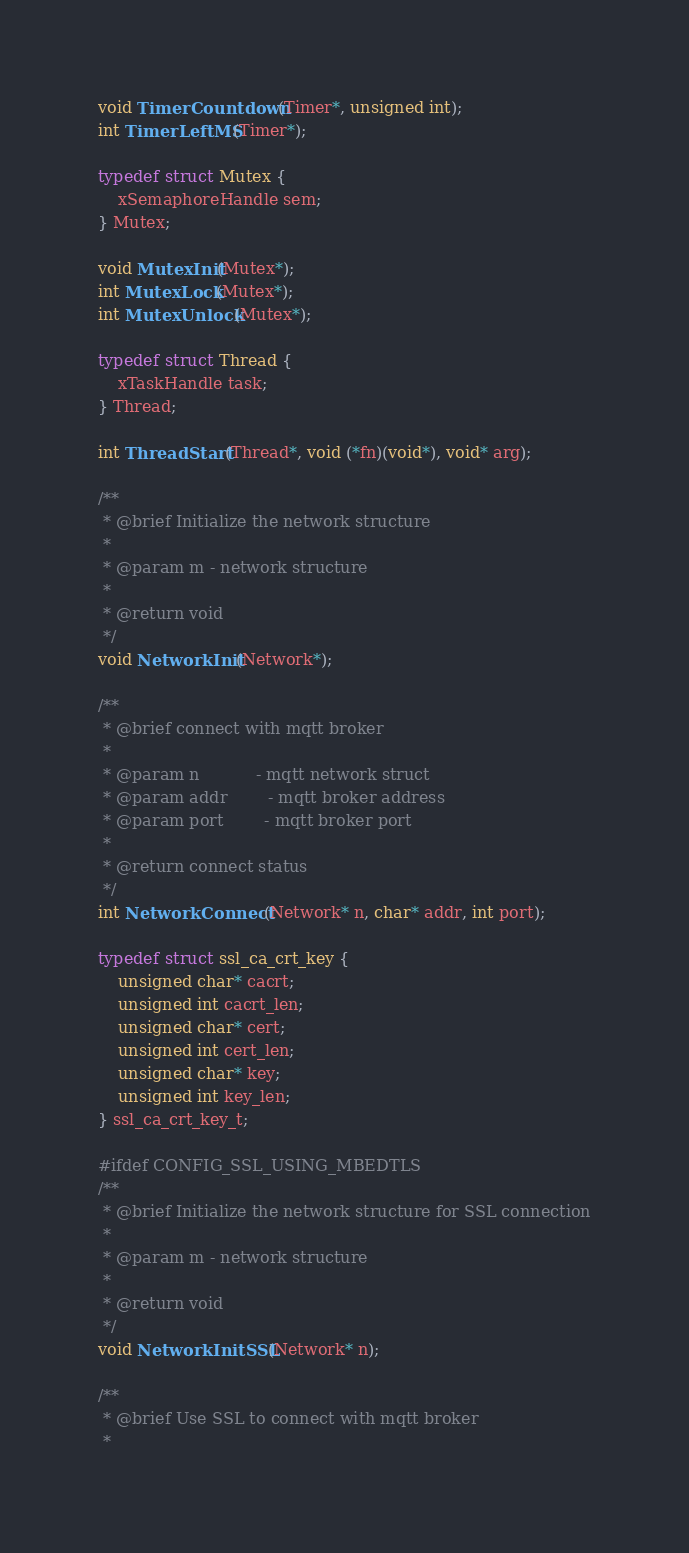Convert code to text. <code><loc_0><loc_0><loc_500><loc_500><_C_>void TimerCountdown(Timer*, unsigned int);
int TimerLeftMS(Timer*);

typedef struct Mutex {
    xSemaphoreHandle sem;
} Mutex;

void MutexInit(Mutex*);
int MutexLock(Mutex*);
int MutexUnlock(Mutex*);

typedef struct Thread {
    xTaskHandle task;
} Thread;

int ThreadStart(Thread*, void (*fn)(void*), void* arg);

/**
 * @brief Initialize the network structure
 *
 * @param m - network structure
 *
 * @return void
 */
void NetworkInit(Network*);

/**
 * @brief connect with mqtt broker
 *
 * @param n           - mqtt network struct
 * @param addr        - mqtt broker address
 * @param port        - mqtt broker port
 *
 * @return connect status
 */
int NetworkConnect(Network* n, char* addr, int port);

typedef struct ssl_ca_crt_key {
    unsigned char* cacrt;
    unsigned int cacrt_len;
    unsigned char* cert;
    unsigned int cert_len;
    unsigned char* key;
    unsigned int key_len;
} ssl_ca_crt_key_t;

#ifdef CONFIG_SSL_USING_MBEDTLS
/**
 * @brief Initialize the network structure for SSL connection
 *
 * @param m - network structure
 *
 * @return void
 */
void NetworkInitSSL(Network* n);

/**
 * @brief Use SSL to connect with mqtt broker
 *</code> 